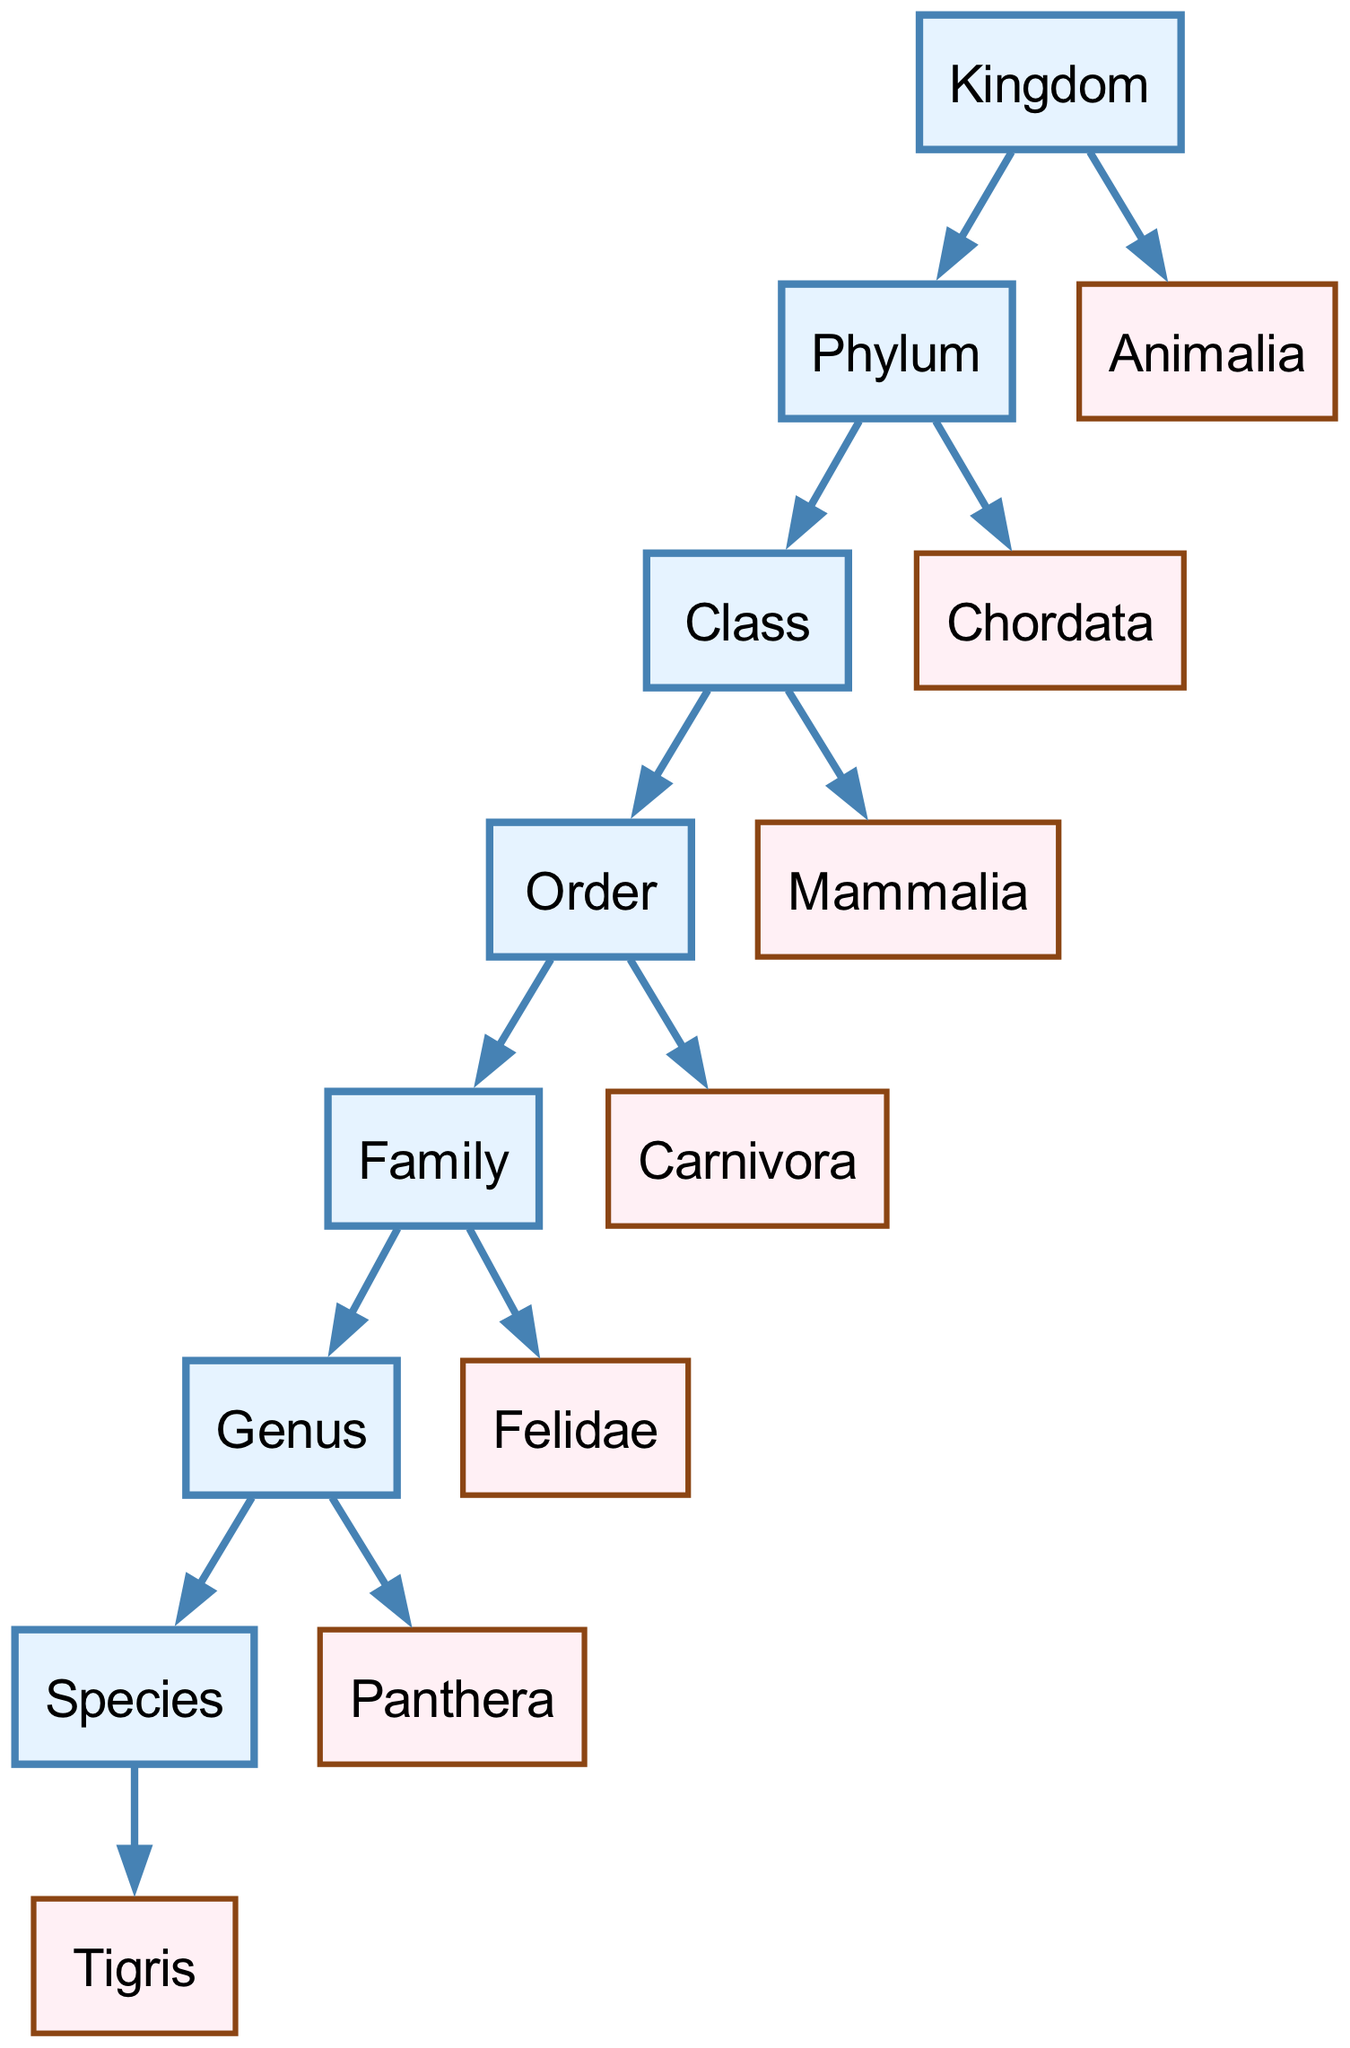What is the highest taxonomic level in the diagram? The highest taxonomic level is depicted by the node "Kingdom," which is the top node in the hierarchical classification structure.
Answer: Kingdom How many nodes represent taxonomic ranks in the hierarchy? The nodes representing taxonomic ranks are Kingdom, Phylum, Class, Order, Family, Genus, and Species. Counting these, we find there are 7 nodes.
Answer: 7 Which taxonomic rank comes directly after "Phylum"? The node that comes directly after "Phylum" in the directed graph is "Class," indicated by the edge that leads from Phylum to Class.
Answer: Class What species is identified at the bottom of the hierarchy? The node at the bottom of the hierarchy representing a specific species is "Tigris," which is directly connected to the Genus node "Panthera."
Answer: Tigris Which family does the genus "Panthera" belong to? The family that is directly linked to the Genus "Panthera" is "Felidae," connected by an edge from Family to Genus.
Answer: Felidae How many edges are present in the directed graph? The edges in the graph connect various taxonomic ranks, and by counting those connections (Kingdom to Phylum and so forth), we find a total of 12 edges.
Answer: 12 What is the relationship between "Order" and "Family"? "Order" is a parent node in the classification leading to "Family," which means "Family" falls under the category of "Order," shown by the directed edge from Order to Family.
Answer: Order to Family Which phylum do mammals belong to? The phylum that encompasses mammals, as shown in the directed graph, is "Chordata," which is connected by an edge from Phylum to Chordata.
Answer: Chordata What is the classification hierarchy starting from "Animalia" down to "Tigris"? The hierarchy starts with "Animalia" (Kingdom), then moves to "Phylum" (Chordata), "Class" (Mammalia), "Order" (Carnivora), "Family" (Felidae), "Genus" (Panthera), and finally to "Species" (Tigris).
Answer: Animalia, Chordata, Mammalia, Carnivora, Felidae, Panthera, Tigris 